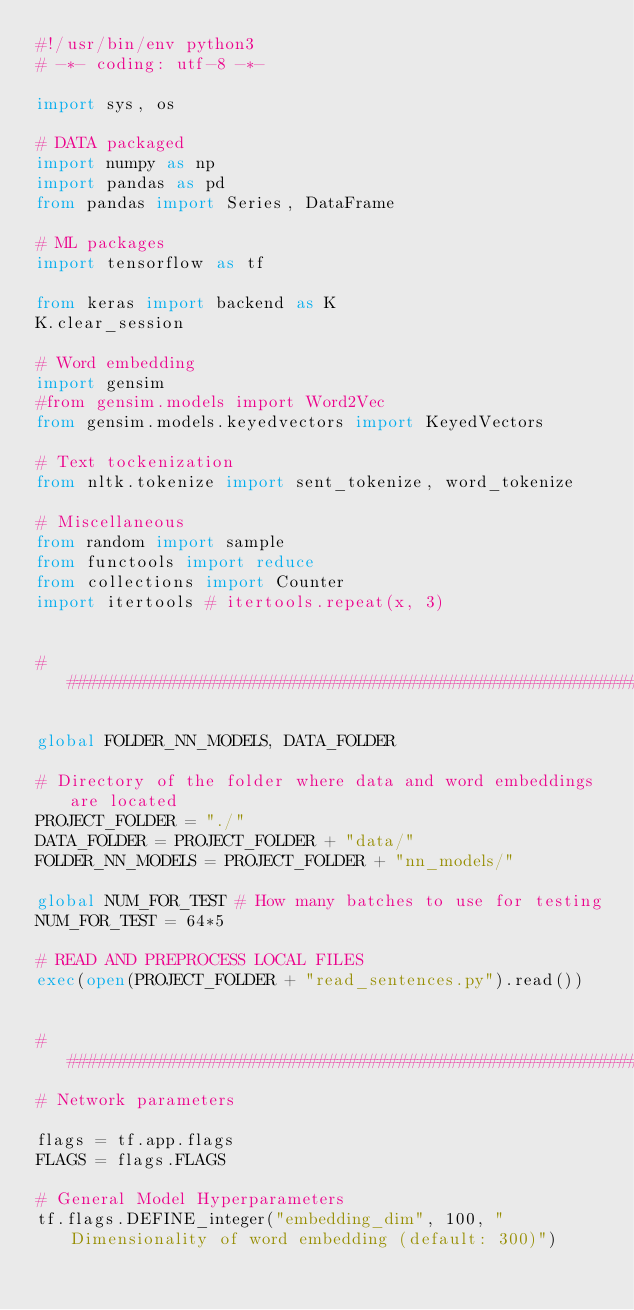Convert code to text. <code><loc_0><loc_0><loc_500><loc_500><_Python_>#!/usr/bin/env python3
# -*- coding: utf-8 -*-

import sys, os

# DATA packaged
import numpy as np
import pandas as pd
from pandas import Series, DataFrame

# ML packages
import tensorflow as tf

from keras import backend as K
K.clear_session

# Word embedding
import gensim
#from gensim.models import Word2Vec
from gensim.models.keyedvectors import KeyedVectors

# Text tockenization
from nltk.tokenize import sent_tokenize, word_tokenize

# Miscellaneous
from random import sample
from functools import reduce
from collections import Counter
import itertools # itertools.repeat(x, 3)


###############################################################################

global FOLDER_NN_MODELS, DATA_FOLDER 

# Directory of the folder where data and word embeddings are located
PROJECT_FOLDER = "./"
DATA_FOLDER = PROJECT_FOLDER + "data/"
FOLDER_NN_MODELS = PROJECT_FOLDER + "nn_models/"

global NUM_FOR_TEST # How many batches to use for testing
NUM_FOR_TEST = 64*5 

# READ AND PREPROCESS LOCAL FILES
exec(open(PROJECT_FOLDER + "read_sentences.py").read())


###############################################################################
# Network parameters

flags = tf.app.flags
FLAGS = flags.FLAGS

# General Model Hyperparameters
tf.flags.DEFINE_integer("embedding_dim", 100, "Dimensionality of word embedding (default: 300)")</code> 